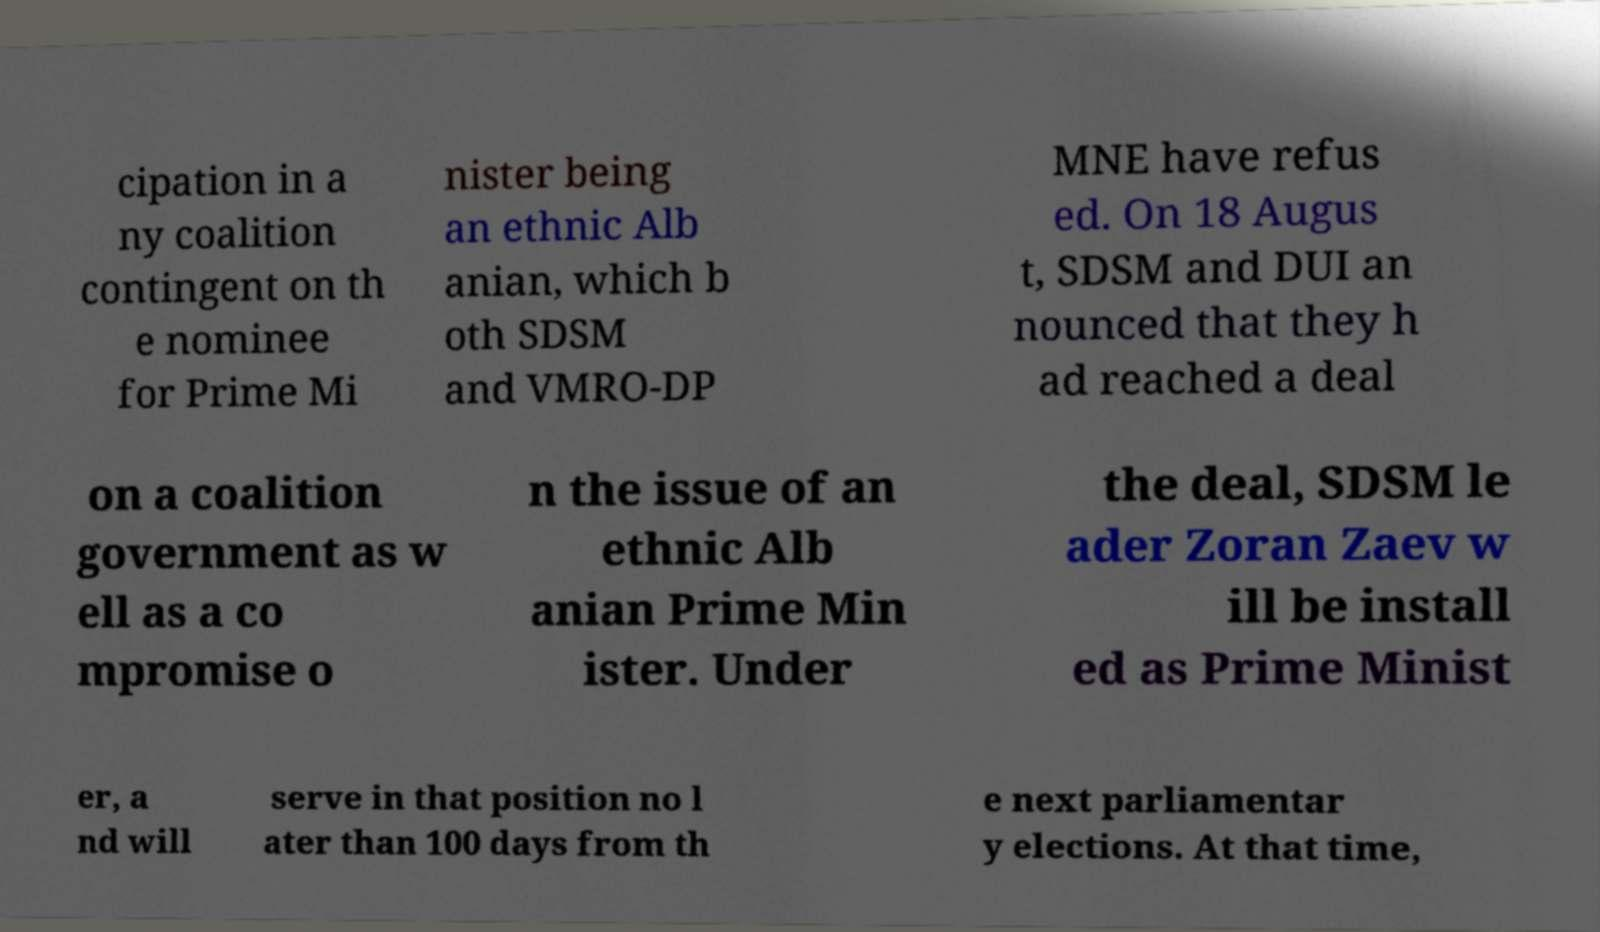Please identify and transcribe the text found in this image. cipation in a ny coalition contingent on th e nominee for Prime Mi nister being an ethnic Alb anian, which b oth SDSM and VMRO-DP MNE have refus ed. On 18 Augus t, SDSM and DUI an nounced that they h ad reached a deal on a coalition government as w ell as a co mpromise o n the issue of an ethnic Alb anian Prime Min ister. Under the deal, SDSM le ader Zoran Zaev w ill be install ed as Prime Minist er, a nd will serve in that position no l ater than 100 days from th e next parliamentar y elections. At that time, 